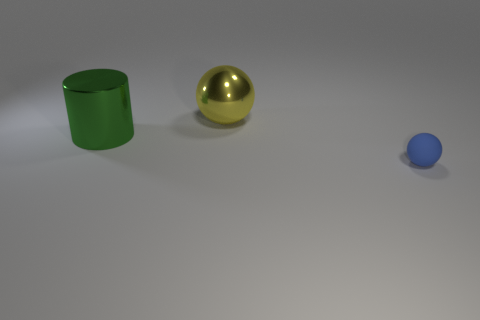Add 2 green cylinders. How many objects exist? 5 Subtract all cylinders. How many objects are left? 2 Subtract all balls. Subtract all green things. How many objects are left? 0 Add 2 metallic spheres. How many metallic spheres are left? 3 Add 1 small yellow metal things. How many small yellow metal things exist? 1 Subtract 0 gray spheres. How many objects are left? 3 